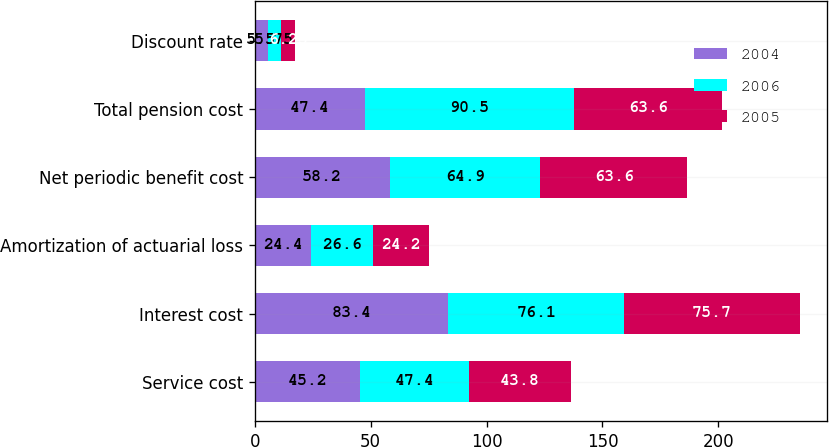<chart> <loc_0><loc_0><loc_500><loc_500><stacked_bar_chart><ecel><fcel>Service cost<fcel>Interest cost<fcel>Amortization of actuarial loss<fcel>Net periodic benefit cost<fcel>Total pension cost<fcel>Discount rate<nl><fcel>2004<fcel>45.2<fcel>83.4<fcel>24.4<fcel>58.2<fcel>47.4<fcel>5.5<nl><fcel>2006<fcel>47.4<fcel>76.1<fcel>26.6<fcel>64.9<fcel>90.5<fcel>5.75<nl><fcel>2005<fcel>43.8<fcel>75.7<fcel>24.2<fcel>63.6<fcel>63.6<fcel>6.25<nl></chart> 